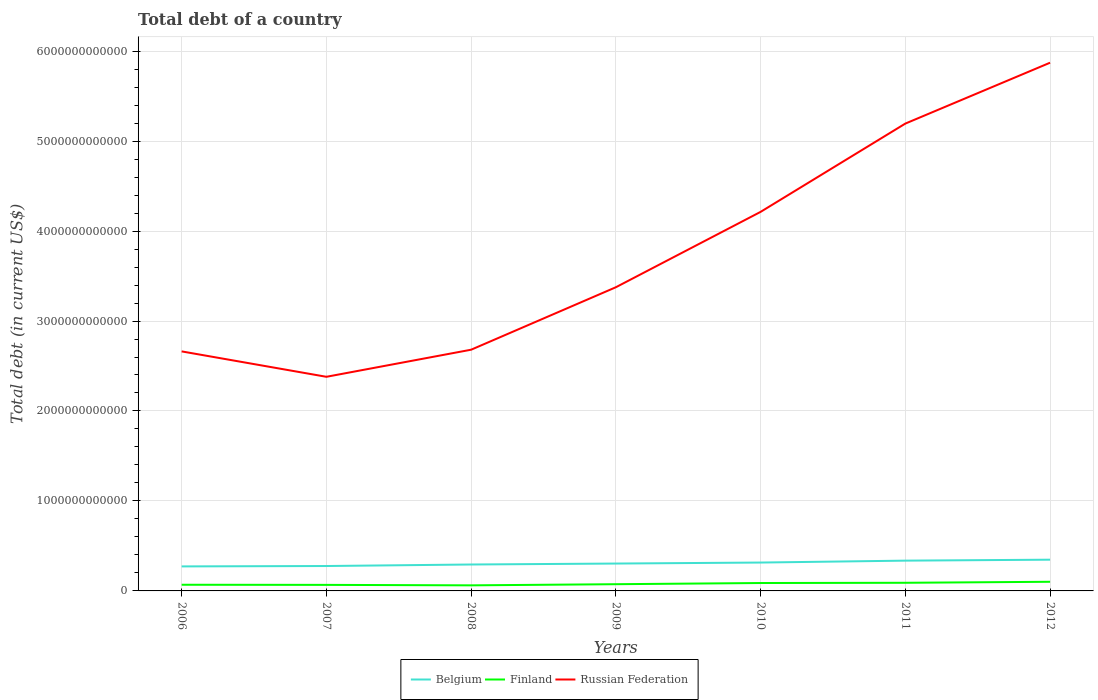Does the line corresponding to Belgium intersect with the line corresponding to Russian Federation?
Your answer should be compact. No. Is the number of lines equal to the number of legend labels?
Give a very brief answer. Yes. Across all years, what is the maximum debt in Belgium?
Your answer should be compact. 2.72e+11. In which year was the debt in Russian Federation maximum?
Provide a short and direct response. 2007. What is the total debt in Finland in the graph?
Your answer should be very brief. -1.58e+1. What is the difference between the highest and the second highest debt in Finland?
Your answer should be compact. 3.96e+1. Is the debt in Belgium strictly greater than the debt in Finland over the years?
Your answer should be very brief. No. How many lines are there?
Offer a terse response. 3. How many years are there in the graph?
Ensure brevity in your answer.  7. What is the difference between two consecutive major ticks on the Y-axis?
Your answer should be very brief. 1.00e+12. Does the graph contain any zero values?
Provide a succinct answer. No. What is the title of the graph?
Offer a very short reply. Total debt of a country. What is the label or title of the Y-axis?
Provide a short and direct response. Total debt (in current US$). What is the Total debt (in current US$) in Belgium in 2006?
Your answer should be very brief. 2.72e+11. What is the Total debt (in current US$) of Finland in 2006?
Offer a very short reply. 6.85e+1. What is the Total debt (in current US$) in Russian Federation in 2006?
Provide a succinct answer. 2.66e+12. What is the Total debt (in current US$) of Belgium in 2007?
Your response must be concise. 2.77e+11. What is the Total debt (in current US$) of Finland in 2007?
Provide a succinct answer. 6.72e+1. What is the Total debt (in current US$) of Russian Federation in 2007?
Ensure brevity in your answer.  2.38e+12. What is the Total debt (in current US$) of Belgium in 2008?
Give a very brief answer. 2.94e+11. What is the Total debt (in current US$) in Finland in 2008?
Offer a very short reply. 6.19e+1. What is the Total debt (in current US$) in Russian Federation in 2008?
Keep it short and to the point. 2.68e+12. What is the Total debt (in current US$) of Belgium in 2009?
Your response must be concise. 3.04e+11. What is the Total debt (in current US$) of Finland in 2009?
Your answer should be very brief. 7.47e+1. What is the Total debt (in current US$) of Russian Federation in 2009?
Keep it short and to the point. 3.38e+12. What is the Total debt (in current US$) of Belgium in 2010?
Provide a succinct answer. 3.15e+11. What is the Total debt (in current US$) of Finland in 2010?
Your answer should be very brief. 8.79e+1. What is the Total debt (in current US$) in Russian Federation in 2010?
Ensure brevity in your answer.  4.21e+12. What is the Total debt (in current US$) of Belgium in 2011?
Offer a terse response. 3.37e+11. What is the Total debt (in current US$) in Finland in 2011?
Offer a terse response. 9.05e+1. What is the Total debt (in current US$) in Russian Federation in 2011?
Provide a short and direct response. 5.19e+12. What is the Total debt (in current US$) of Belgium in 2012?
Keep it short and to the point. 3.47e+11. What is the Total debt (in current US$) of Finland in 2012?
Your answer should be compact. 1.02e+11. What is the Total debt (in current US$) of Russian Federation in 2012?
Your answer should be very brief. 5.87e+12. Across all years, what is the maximum Total debt (in current US$) of Belgium?
Offer a terse response. 3.47e+11. Across all years, what is the maximum Total debt (in current US$) in Finland?
Your response must be concise. 1.02e+11. Across all years, what is the maximum Total debt (in current US$) of Russian Federation?
Make the answer very short. 5.87e+12. Across all years, what is the minimum Total debt (in current US$) in Belgium?
Your answer should be very brief. 2.72e+11. Across all years, what is the minimum Total debt (in current US$) in Finland?
Keep it short and to the point. 6.19e+1. Across all years, what is the minimum Total debt (in current US$) of Russian Federation?
Make the answer very short. 2.38e+12. What is the total Total debt (in current US$) in Belgium in the graph?
Provide a short and direct response. 2.15e+12. What is the total Total debt (in current US$) in Finland in the graph?
Provide a succinct answer. 5.52e+11. What is the total Total debt (in current US$) of Russian Federation in the graph?
Provide a succinct answer. 2.64e+13. What is the difference between the Total debt (in current US$) in Belgium in 2006 and that in 2007?
Give a very brief answer. -4.37e+09. What is the difference between the Total debt (in current US$) of Finland in 2006 and that in 2007?
Your answer should be very brief. 1.32e+09. What is the difference between the Total debt (in current US$) in Russian Federation in 2006 and that in 2007?
Provide a succinct answer. 2.82e+11. What is the difference between the Total debt (in current US$) in Belgium in 2006 and that in 2008?
Ensure brevity in your answer.  -2.12e+1. What is the difference between the Total debt (in current US$) in Finland in 2006 and that in 2008?
Offer a terse response. 6.59e+09. What is the difference between the Total debt (in current US$) in Russian Federation in 2006 and that in 2008?
Ensure brevity in your answer.  -1.87e+1. What is the difference between the Total debt (in current US$) in Belgium in 2006 and that in 2009?
Make the answer very short. -3.18e+1. What is the difference between the Total debt (in current US$) of Finland in 2006 and that in 2009?
Keep it short and to the point. -6.14e+09. What is the difference between the Total debt (in current US$) of Russian Federation in 2006 and that in 2009?
Your answer should be very brief. -7.13e+11. What is the difference between the Total debt (in current US$) in Belgium in 2006 and that in 2010?
Keep it short and to the point. -4.30e+1. What is the difference between the Total debt (in current US$) in Finland in 2006 and that in 2010?
Your answer should be very brief. -1.94e+1. What is the difference between the Total debt (in current US$) of Russian Federation in 2006 and that in 2010?
Ensure brevity in your answer.  -1.55e+12. What is the difference between the Total debt (in current US$) in Belgium in 2006 and that in 2011?
Ensure brevity in your answer.  -6.41e+1. What is the difference between the Total debt (in current US$) in Finland in 2006 and that in 2011?
Give a very brief answer. -2.20e+1. What is the difference between the Total debt (in current US$) of Russian Federation in 2006 and that in 2011?
Your answer should be very brief. -2.53e+12. What is the difference between the Total debt (in current US$) of Belgium in 2006 and that in 2012?
Your response must be concise. -7.48e+1. What is the difference between the Total debt (in current US$) of Finland in 2006 and that in 2012?
Keep it short and to the point. -3.30e+1. What is the difference between the Total debt (in current US$) in Russian Federation in 2006 and that in 2012?
Keep it short and to the point. -3.21e+12. What is the difference between the Total debt (in current US$) in Belgium in 2007 and that in 2008?
Your answer should be compact. -1.69e+1. What is the difference between the Total debt (in current US$) of Finland in 2007 and that in 2008?
Provide a short and direct response. 5.27e+09. What is the difference between the Total debt (in current US$) of Russian Federation in 2007 and that in 2008?
Offer a terse response. -3.01e+11. What is the difference between the Total debt (in current US$) of Belgium in 2007 and that in 2009?
Give a very brief answer. -2.75e+1. What is the difference between the Total debt (in current US$) in Finland in 2007 and that in 2009?
Your answer should be compact. -7.46e+09. What is the difference between the Total debt (in current US$) in Russian Federation in 2007 and that in 2009?
Provide a succinct answer. -9.95e+11. What is the difference between the Total debt (in current US$) in Belgium in 2007 and that in 2010?
Your answer should be compact. -3.86e+1. What is the difference between the Total debt (in current US$) of Finland in 2007 and that in 2010?
Provide a short and direct response. -2.07e+1. What is the difference between the Total debt (in current US$) in Russian Federation in 2007 and that in 2010?
Offer a terse response. -1.83e+12. What is the difference between the Total debt (in current US$) in Belgium in 2007 and that in 2011?
Your answer should be very brief. -5.98e+1. What is the difference between the Total debt (in current US$) of Finland in 2007 and that in 2011?
Your answer should be compact. -2.33e+1. What is the difference between the Total debt (in current US$) of Russian Federation in 2007 and that in 2011?
Give a very brief answer. -2.81e+12. What is the difference between the Total debt (in current US$) in Belgium in 2007 and that in 2012?
Provide a succinct answer. -7.05e+1. What is the difference between the Total debt (in current US$) in Finland in 2007 and that in 2012?
Give a very brief answer. -3.43e+1. What is the difference between the Total debt (in current US$) in Russian Federation in 2007 and that in 2012?
Ensure brevity in your answer.  -3.49e+12. What is the difference between the Total debt (in current US$) in Belgium in 2008 and that in 2009?
Ensure brevity in your answer.  -1.06e+1. What is the difference between the Total debt (in current US$) of Finland in 2008 and that in 2009?
Offer a terse response. -1.27e+1. What is the difference between the Total debt (in current US$) in Russian Federation in 2008 and that in 2009?
Offer a terse response. -6.94e+11. What is the difference between the Total debt (in current US$) of Belgium in 2008 and that in 2010?
Your answer should be compact. -2.18e+1. What is the difference between the Total debt (in current US$) of Finland in 2008 and that in 2010?
Your answer should be very brief. -2.60e+1. What is the difference between the Total debt (in current US$) in Russian Federation in 2008 and that in 2010?
Your answer should be compact. -1.53e+12. What is the difference between the Total debt (in current US$) of Belgium in 2008 and that in 2011?
Your answer should be compact. -4.29e+1. What is the difference between the Total debt (in current US$) in Finland in 2008 and that in 2011?
Provide a succinct answer. -2.86e+1. What is the difference between the Total debt (in current US$) of Russian Federation in 2008 and that in 2011?
Your answer should be very brief. -2.51e+12. What is the difference between the Total debt (in current US$) in Belgium in 2008 and that in 2012?
Ensure brevity in your answer.  -5.36e+1. What is the difference between the Total debt (in current US$) of Finland in 2008 and that in 2012?
Provide a short and direct response. -3.96e+1. What is the difference between the Total debt (in current US$) in Russian Federation in 2008 and that in 2012?
Provide a short and direct response. -3.19e+12. What is the difference between the Total debt (in current US$) in Belgium in 2009 and that in 2010?
Your answer should be compact. -1.12e+1. What is the difference between the Total debt (in current US$) of Finland in 2009 and that in 2010?
Provide a short and direct response. -1.33e+1. What is the difference between the Total debt (in current US$) of Russian Federation in 2009 and that in 2010?
Keep it short and to the point. -8.38e+11. What is the difference between the Total debt (in current US$) in Belgium in 2009 and that in 2011?
Offer a very short reply. -3.23e+1. What is the difference between the Total debt (in current US$) in Finland in 2009 and that in 2011?
Your answer should be very brief. -1.58e+1. What is the difference between the Total debt (in current US$) of Russian Federation in 2009 and that in 2011?
Your response must be concise. -1.82e+12. What is the difference between the Total debt (in current US$) of Belgium in 2009 and that in 2012?
Provide a short and direct response. -4.30e+1. What is the difference between the Total debt (in current US$) of Finland in 2009 and that in 2012?
Give a very brief answer. -2.69e+1. What is the difference between the Total debt (in current US$) of Russian Federation in 2009 and that in 2012?
Offer a very short reply. -2.50e+12. What is the difference between the Total debt (in current US$) in Belgium in 2010 and that in 2011?
Offer a terse response. -2.11e+1. What is the difference between the Total debt (in current US$) of Finland in 2010 and that in 2011?
Offer a very short reply. -2.55e+09. What is the difference between the Total debt (in current US$) of Russian Federation in 2010 and that in 2011?
Offer a very short reply. -9.81e+11. What is the difference between the Total debt (in current US$) of Belgium in 2010 and that in 2012?
Provide a short and direct response. -3.18e+1. What is the difference between the Total debt (in current US$) in Finland in 2010 and that in 2012?
Provide a short and direct response. -1.36e+1. What is the difference between the Total debt (in current US$) in Russian Federation in 2010 and that in 2012?
Provide a short and direct response. -1.66e+12. What is the difference between the Total debt (in current US$) in Belgium in 2011 and that in 2012?
Ensure brevity in your answer.  -1.07e+1. What is the difference between the Total debt (in current US$) of Finland in 2011 and that in 2012?
Offer a terse response. -1.11e+1. What is the difference between the Total debt (in current US$) of Russian Federation in 2011 and that in 2012?
Keep it short and to the point. -6.77e+11. What is the difference between the Total debt (in current US$) of Belgium in 2006 and the Total debt (in current US$) of Finland in 2007?
Make the answer very short. 2.05e+11. What is the difference between the Total debt (in current US$) of Belgium in 2006 and the Total debt (in current US$) of Russian Federation in 2007?
Your answer should be very brief. -2.11e+12. What is the difference between the Total debt (in current US$) in Finland in 2006 and the Total debt (in current US$) in Russian Federation in 2007?
Your response must be concise. -2.31e+12. What is the difference between the Total debt (in current US$) in Belgium in 2006 and the Total debt (in current US$) in Finland in 2008?
Offer a terse response. 2.10e+11. What is the difference between the Total debt (in current US$) in Belgium in 2006 and the Total debt (in current US$) in Russian Federation in 2008?
Make the answer very short. -2.41e+12. What is the difference between the Total debt (in current US$) of Finland in 2006 and the Total debt (in current US$) of Russian Federation in 2008?
Offer a terse response. -2.61e+12. What is the difference between the Total debt (in current US$) of Belgium in 2006 and the Total debt (in current US$) of Finland in 2009?
Offer a very short reply. 1.98e+11. What is the difference between the Total debt (in current US$) of Belgium in 2006 and the Total debt (in current US$) of Russian Federation in 2009?
Keep it short and to the point. -3.10e+12. What is the difference between the Total debt (in current US$) of Finland in 2006 and the Total debt (in current US$) of Russian Federation in 2009?
Make the answer very short. -3.31e+12. What is the difference between the Total debt (in current US$) of Belgium in 2006 and the Total debt (in current US$) of Finland in 2010?
Provide a succinct answer. 1.84e+11. What is the difference between the Total debt (in current US$) of Belgium in 2006 and the Total debt (in current US$) of Russian Federation in 2010?
Your answer should be compact. -3.94e+12. What is the difference between the Total debt (in current US$) of Finland in 2006 and the Total debt (in current US$) of Russian Federation in 2010?
Offer a terse response. -4.14e+12. What is the difference between the Total debt (in current US$) of Belgium in 2006 and the Total debt (in current US$) of Finland in 2011?
Offer a very short reply. 1.82e+11. What is the difference between the Total debt (in current US$) in Belgium in 2006 and the Total debt (in current US$) in Russian Federation in 2011?
Offer a terse response. -4.92e+12. What is the difference between the Total debt (in current US$) in Finland in 2006 and the Total debt (in current US$) in Russian Federation in 2011?
Make the answer very short. -5.13e+12. What is the difference between the Total debt (in current US$) in Belgium in 2006 and the Total debt (in current US$) in Finland in 2012?
Give a very brief answer. 1.71e+11. What is the difference between the Total debt (in current US$) of Belgium in 2006 and the Total debt (in current US$) of Russian Federation in 2012?
Your answer should be very brief. -5.60e+12. What is the difference between the Total debt (in current US$) in Finland in 2006 and the Total debt (in current US$) in Russian Federation in 2012?
Your response must be concise. -5.80e+12. What is the difference between the Total debt (in current US$) of Belgium in 2007 and the Total debt (in current US$) of Finland in 2008?
Provide a succinct answer. 2.15e+11. What is the difference between the Total debt (in current US$) in Belgium in 2007 and the Total debt (in current US$) in Russian Federation in 2008?
Make the answer very short. -2.40e+12. What is the difference between the Total debt (in current US$) of Finland in 2007 and the Total debt (in current US$) of Russian Federation in 2008?
Your response must be concise. -2.61e+12. What is the difference between the Total debt (in current US$) of Belgium in 2007 and the Total debt (in current US$) of Finland in 2009?
Your answer should be very brief. 2.02e+11. What is the difference between the Total debt (in current US$) in Belgium in 2007 and the Total debt (in current US$) in Russian Federation in 2009?
Provide a succinct answer. -3.10e+12. What is the difference between the Total debt (in current US$) in Finland in 2007 and the Total debt (in current US$) in Russian Federation in 2009?
Offer a terse response. -3.31e+12. What is the difference between the Total debt (in current US$) in Belgium in 2007 and the Total debt (in current US$) in Finland in 2010?
Keep it short and to the point. 1.89e+11. What is the difference between the Total debt (in current US$) of Belgium in 2007 and the Total debt (in current US$) of Russian Federation in 2010?
Your answer should be very brief. -3.94e+12. What is the difference between the Total debt (in current US$) of Finland in 2007 and the Total debt (in current US$) of Russian Federation in 2010?
Provide a succinct answer. -4.15e+12. What is the difference between the Total debt (in current US$) in Belgium in 2007 and the Total debt (in current US$) in Finland in 2011?
Give a very brief answer. 1.86e+11. What is the difference between the Total debt (in current US$) in Belgium in 2007 and the Total debt (in current US$) in Russian Federation in 2011?
Provide a short and direct response. -4.92e+12. What is the difference between the Total debt (in current US$) of Finland in 2007 and the Total debt (in current US$) of Russian Federation in 2011?
Keep it short and to the point. -5.13e+12. What is the difference between the Total debt (in current US$) in Belgium in 2007 and the Total debt (in current US$) in Finland in 2012?
Make the answer very short. 1.75e+11. What is the difference between the Total debt (in current US$) in Belgium in 2007 and the Total debt (in current US$) in Russian Federation in 2012?
Keep it short and to the point. -5.59e+12. What is the difference between the Total debt (in current US$) in Finland in 2007 and the Total debt (in current US$) in Russian Federation in 2012?
Provide a succinct answer. -5.80e+12. What is the difference between the Total debt (in current US$) of Belgium in 2008 and the Total debt (in current US$) of Finland in 2009?
Provide a short and direct response. 2.19e+11. What is the difference between the Total debt (in current US$) of Belgium in 2008 and the Total debt (in current US$) of Russian Federation in 2009?
Give a very brief answer. -3.08e+12. What is the difference between the Total debt (in current US$) of Finland in 2008 and the Total debt (in current US$) of Russian Federation in 2009?
Provide a succinct answer. -3.31e+12. What is the difference between the Total debt (in current US$) of Belgium in 2008 and the Total debt (in current US$) of Finland in 2010?
Give a very brief answer. 2.06e+11. What is the difference between the Total debt (in current US$) in Belgium in 2008 and the Total debt (in current US$) in Russian Federation in 2010?
Offer a terse response. -3.92e+12. What is the difference between the Total debt (in current US$) in Finland in 2008 and the Total debt (in current US$) in Russian Federation in 2010?
Your response must be concise. -4.15e+12. What is the difference between the Total debt (in current US$) in Belgium in 2008 and the Total debt (in current US$) in Finland in 2011?
Your answer should be very brief. 2.03e+11. What is the difference between the Total debt (in current US$) in Belgium in 2008 and the Total debt (in current US$) in Russian Federation in 2011?
Make the answer very short. -4.90e+12. What is the difference between the Total debt (in current US$) in Finland in 2008 and the Total debt (in current US$) in Russian Federation in 2011?
Offer a terse response. -5.13e+12. What is the difference between the Total debt (in current US$) in Belgium in 2008 and the Total debt (in current US$) in Finland in 2012?
Provide a succinct answer. 1.92e+11. What is the difference between the Total debt (in current US$) in Belgium in 2008 and the Total debt (in current US$) in Russian Federation in 2012?
Your answer should be very brief. -5.58e+12. What is the difference between the Total debt (in current US$) of Finland in 2008 and the Total debt (in current US$) of Russian Federation in 2012?
Ensure brevity in your answer.  -5.81e+12. What is the difference between the Total debt (in current US$) of Belgium in 2009 and the Total debt (in current US$) of Finland in 2010?
Keep it short and to the point. 2.16e+11. What is the difference between the Total debt (in current US$) of Belgium in 2009 and the Total debt (in current US$) of Russian Federation in 2010?
Make the answer very short. -3.91e+12. What is the difference between the Total debt (in current US$) of Finland in 2009 and the Total debt (in current US$) of Russian Federation in 2010?
Give a very brief answer. -4.14e+12. What is the difference between the Total debt (in current US$) in Belgium in 2009 and the Total debt (in current US$) in Finland in 2011?
Make the answer very short. 2.14e+11. What is the difference between the Total debt (in current US$) in Belgium in 2009 and the Total debt (in current US$) in Russian Federation in 2011?
Provide a short and direct response. -4.89e+12. What is the difference between the Total debt (in current US$) of Finland in 2009 and the Total debt (in current US$) of Russian Federation in 2011?
Your answer should be compact. -5.12e+12. What is the difference between the Total debt (in current US$) in Belgium in 2009 and the Total debt (in current US$) in Finland in 2012?
Give a very brief answer. 2.03e+11. What is the difference between the Total debt (in current US$) in Belgium in 2009 and the Total debt (in current US$) in Russian Federation in 2012?
Offer a very short reply. -5.57e+12. What is the difference between the Total debt (in current US$) of Finland in 2009 and the Total debt (in current US$) of Russian Federation in 2012?
Offer a very short reply. -5.80e+12. What is the difference between the Total debt (in current US$) in Belgium in 2010 and the Total debt (in current US$) in Finland in 2011?
Your response must be concise. 2.25e+11. What is the difference between the Total debt (in current US$) of Belgium in 2010 and the Total debt (in current US$) of Russian Federation in 2011?
Your answer should be compact. -4.88e+12. What is the difference between the Total debt (in current US$) of Finland in 2010 and the Total debt (in current US$) of Russian Federation in 2011?
Offer a very short reply. -5.11e+12. What is the difference between the Total debt (in current US$) of Belgium in 2010 and the Total debt (in current US$) of Finland in 2012?
Provide a succinct answer. 2.14e+11. What is the difference between the Total debt (in current US$) of Belgium in 2010 and the Total debt (in current US$) of Russian Federation in 2012?
Ensure brevity in your answer.  -5.56e+12. What is the difference between the Total debt (in current US$) in Finland in 2010 and the Total debt (in current US$) in Russian Federation in 2012?
Your answer should be compact. -5.78e+12. What is the difference between the Total debt (in current US$) of Belgium in 2011 and the Total debt (in current US$) of Finland in 2012?
Make the answer very short. 2.35e+11. What is the difference between the Total debt (in current US$) of Belgium in 2011 and the Total debt (in current US$) of Russian Federation in 2012?
Give a very brief answer. -5.53e+12. What is the difference between the Total debt (in current US$) of Finland in 2011 and the Total debt (in current US$) of Russian Federation in 2012?
Your answer should be very brief. -5.78e+12. What is the average Total debt (in current US$) of Belgium per year?
Provide a short and direct response. 3.07e+11. What is the average Total debt (in current US$) in Finland per year?
Ensure brevity in your answer.  7.89e+1. What is the average Total debt (in current US$) in Russian Federation per year?
Keep it short and to the point. 3.77e+12. In the year 2006, what is the difference between the Total debt (in current US$) in Belgium and Total debt (in current US$) in Finland?
Your response must be concise. 2.04e+11. In the year 2006, what is the difference between the Total debt (in current US$) in Belgium and Total debt (in current US$) in Russian Federation?
Offer a terse response. -2.39e+12. In the year 2006, what is the difference between the Total debt (in current US$) in Finland and Total debt (in current US$) in Russian Federation?
Offer a very short reply. -2.59e+12. In the year 2007, what is the difference between the Total debt (in current US$) in Belgium and Total debt (in current US$) in Finland?
Ensure brevity in your answer.  2.10e+11. In the year 2007, what is the difference between the Total debt (in current US$) of Belgium and Total debt (in current US$) of Russian Federation?
Provide a succinct answer. -2.10e+12. In the year 2007, what is the difference between the Total debt (in current US$) of Finland and Total debt (in current US$) of Russian Federation?
Your answer should be compact. -2.31e+12. In the year 2008, what is the difference between the Total debt (in current US$) of Belgium and Total debt (in current US$) of Finland?
Offer a terse response. 2.32e+11. In the year 2008, what is the difference between the Total debt (in current US$) of Belgium and Total debt (in current US$) of Russian Federation?
Give a very brief answer. -2.39e+12. In the year 2008, what is the difference between the Total debt (in current US$) in Finland and Total debt (in current US$) in Russian Federation?
Make the answer very short. -2.62e+12. In the year 2009, what is the difference between the Total debt (in current US$) in Belgium and Total debt (in current US$) in Finland?
Give a very brief answer. 2.30e+11. In the year 2009, what is the difference between the Total debt (in current US$) in Belgium and Total debt (in current US$) in Russian Federation?
Provide a short and direct response. -3.07e+12. In the year 2009, what is the difference between the Total debt (in current US$) of Finland and Total debt (in current US$) of Russian Federation?
Provide a short and direct response. -3.30e+12. In the year 2010, what is the difference between the Total debt (in current US$) of Belgium and Total debt (in current US$) of Finland?
Your answer should be compact. 2.27e+11. In the year 2010, what is the difference between the Total debt (in current US$) of Belgium and Total debt (in current US$) of Russian Federation?
Provide a short and direct response. -3.90e+12. In the year 2010, what is the difference between the Total debt (in current US$) in Finland and Total debt (in current US$) in Russian Federation?
Keep it short and to the point. -4.13e+12. In the year 2011, what is the difference between the Total debt (in current US$) in Belgium and Total debt (in current US$) in Finland?
Provide a short and direct response. 2.46e+11. In the year 2011, what is the difference between the Total debt (in current US$) of Belgium and Total debt (in current US$) of Russian Federation?
Offer a terse response. -4.86e+12. In the year 2011, what is the difference between the Total debt (in current US$) of Finland and Total debt (in current US$) of Russian Federation?
Provide a succinct answer. -5.10e+12. In the year 2012, what is the difference between the Total debt (in current US$) of Belgium and Total debt (in current US$) of Finland?
Give a very brief answer. 2.46e+11. In the year 2012, what is the difference between the Total debt (in current US$) in Belgium and Total debt (in current US$) in Russian Federation?
Make the answer very short. -5.52e+12. In the year 2012, what is the difference between the Total debt (in current US$) of Finland and Total debt (in current US$) of Russian Federation?
Keep it short and to the point. -5.77e+12. What is the ratio of the Total debt (in current US$) in Belgium in 2006 to that in 2007?
Keep it short and to the point. 0.98. What is the ratio of the Total debt (in current US$) in Finland in 2006 to that in 2007?
Offer a very short reply. 1.02. What is the ratio of the Total debt (in current US$) of Russian Federation in 2006 to that in 2007?
Offer a very short reply. 1.12. What is the ratio of the Total debt (in current US$) in Belgium in 2006 to that in 2008?
Provide a short and direct response. 0.93. What is the ratio of the Total debt (in current US$) of Finland in 2006 to that in 2008?
Your response must be concise. 1.11. What is the ratio of the Total debt (in current US$) in Belgium in 2006 to that in 2009?
Keep it short and to the point. 0.9. What is the ratio of the Total debt (in current US$) of Finland in 2006 to that in 2009?
Ensure brevity in your answer.  0.92. What is the ratio of the Total debt (in current US$) of Russian Federation in 2006 to that in 2009?
Ensure brevity in your answer.  0.79. What is the ratio of the Total debt (in current US$) of Belgium in 2006 to that in 2010?
Offer a very short reply. 0.86. What is the ratio of the Total debt (in current US$) of Finland in 2006 to that in 2010?
Your response must be concise. 0.78. What is the ratio of the Total debt (in current US$) of Russian Federation in 2006 to that in 2010?
Make the answer very short. 0.63. What is the ratio of the Total debt (in current US$) in Belgium in 2006 to that in 2011?
Your answer should be compact. 0.81. What is the ratio of the Total debt (in current US$) in Finland in 2006 to that in 2011?
Provide a succinct answer. 0.76. What is the ratio of the Total debt (in current US$) of Russian Federation in 2006 to that in 2011?
Provide a short and direct response. 0.51. What is the ratio of the Total debt (in current US$) of Belgium in 2006 to that in 2012?
Offer a very short reply. 0.78. What is the ratio of the Total debt (in current US$) of Finland in 2006 to that in 2012?
Ensure brevity in your answer.  0.67. What is the ratio of the Total debt (in current US$) of Russian Federation in 2006 to that in 2012?
Offer a terse response. 0.45. What is the ratio of the Total debt (in current US$) in Belgium in 2007 to that in 2008?
Keep it short and to the point. 0.94. What is the ratio of the Total debt (in current US$) of Finland in 2007 to that in 2008?
Keep it short and to the point. 1.09. What is the ratio of the Total debt (in current US$) in Russian Federation in 2007 to that in 2008?
Offer a terse response. 0.89. What is the ratio of the Total debt (in current US$) in Belgium in 2007 to that in 2009?
Make the answer very short. 0.91. What is the ratio of the Total debt (in current US$) in Finland in 2007 to that in 2009?
Provide a short and direct response. 0.9. What is the ratio of the Total debt (in current US$) in Russian Federation in 2007 to that in 2009?
Keep it short and to the point. 0.71. What is the ratio of the Total debt (in current US$) of Belgium in 2007 to that in 2010?
Your answer should be compact. 0.88. What is the ratio of the Total debt (in current US$) of Finland in 2007 to that in 2010?
Ensure brevity in your answer.  0.76. What is the ratio of the Total debt (in current US$) in Russian Federation in 2007 to that in 2010?
Ensure brevity in your answer.  0.56. What is the ratio of the Total debt (in current US$) in Belgium in 2007 to that in 2011?
Keep it short and to the point. 0.82. What is the ratio of the Total debt (in current US$) in Finland in 2007 to that in 2011?
Your answer should be compact. 0.74. What is the ratio of the Total debt (in current US$) of Russian Federation in 2007 to that in 2011?
Ensure brevity in your answer.  0.46. What is the ratio of the Total debt (in current US$) in Belgium in 2007 to that in 2012?
Your answer should be compact. 0.8. What is the ratio of the Total debt (in current US$) of Finland in 2007 to that in 2012?
Provide a short and direct response. 0.66. What is the ratio of the Total debt (in current US$) of Russian Federation in 2007 to that in 2012?
Make the answer very short. 0.41. What is the ratio of the Total debt (in current US$) in Belgium in 2008 to that in 2009?
Your response must be concise. 0.97. What is the ratio of the Total debt (in current US$) of Finland in 2008 to that in 2009?
Give a very brief answer. 0.83. What is the ratio of the Total debt (in current US$) of Russian Federation in 2008 to that in 2009?
Provide a succinct answer. 0.79. What is the ratio of the Total debt (in current US$) in Belgium in 2008 to that in 2010?
Offer a terse response. 0.93. What is the ratio of the Total debt (in current US$) in Finland in 2008 to that in 2010?
Make the answer very short. 0.7. What is the ratio of the Total debt (in current US$) of Russian Federation in 2008 to that in 2010?
Offer a very short reply. 0.64. What is the ratio of the Total debt (in current US$) of Belgium in 2008 to that in 2011?
Your response must be concise. 0.87. What is the ratio of the Total debt (in current US$) of Finland in 2008 to that in 2011?
Your answer should be compact. 0.68. What is the ratio of the Total debt (in current US$) in Russian Federation in 2008 to that in 2011?
Provide a short and direct response. 0.52. What is the ratio of the Total debt (in current US$) in Belgium in 2008 to that in 2012?
Your answer should be very brief. 0.85. What is the ratio of the Total debt (in current US$) of Finland in 2008 to that in 2012?
Make the answer very short. 0.61. What is the ratio of the Total debt (in current US$) in Russian Federation in 2008 to that in 2012?
Make the answer very short. 0.46. What is the ratio of the Total debt (in current US$) in Belgium in 2009 to that in 2010?
Offer a terse response. 0.96. What is the ratio of the Total debt (in current US$) of Finland in 2009 to that in 2010?
Your answer should be very brief. 0.85. What is the ratio of the Total debt (in current US$) of Russian Federation in 2009 to that in 2010?
Your answer should be very brief. 0.8. What is the ratio of the Total debt (in current US$) in Belgium in 2009 to that in 2011?
Your response must be concise. 0.9. What is the ratio of the Total debt (in current US$) of Finland in 2009 to that in 2011?
Your answer should be very brief. 0.83. What is the ratio of the Total debt (in current US$) of Russian Federation in 2009 to that in 2011?
Offer a very short reply. 0.65. What is the ratio of the Total debt (in current US$) in Belgium in 2009 to that in 2012?
Keep it short and to the point. 0.88. What is the ratio of the Total debt (in current US$) in Finland in 2009 to that in 2012?
Your answer should be compact. 0.74. What is the ratio of the Total debt (in current US$) of Russian Federation in 2009 to that in 2012?
Your response must be concise. 0.57. What is the ratio of the Total debt (in current US$) of Belgium in 2010 to that in 2011?
Make the answer very short. 0.94. What is the ratio of the Total debt (in current US$) in Finland in 2010 to that in 2011?
Your answer should be very brief. 0.97. What is the ratio of the Total debt (in current US$) in Russian Federation in 2010 to that in 2011?
Keep it short and to the point. 0.81. What is the ratio of the Total debt (in current US$) in Belgium in 2010 to that in 2012?
Your answer should be compact. 0.91. What is the ratio of the Total debt (in current US$) of Finland in 2010 to that in 2012?
Provide a short and direct response. 0.87. What is the ratio of the Total debt (in current US$) of Russian Federation in 2010 to that in 2012?
Provide a succinct answer. 0.72. What is the ratio of the Total debt (in current US$) of Belgium in 2011 to that in 2012?
Give a very brief answer. 0.97. What is the ratio of the Total debt (in current US$) in Finland in 2011 to that in 2012?
Your response must be concise. 0.89. What is the ratio of the Total debt (in current US$) of Russian Federation in 2011 to that in 2012?
Ensure brevity in your answer.  0.88. What is the difference between the highest and the second highest Total debt (in current US$) of Belgium?
Provide a succinct answer. 1.07e+1. What is the difference between the highest and the second highest Total debt (in current US$) in Finland?
Your answer should be compact. 1.11e+1. What is the difference between the highest and the second highest Total debt (in current US$) in Russian Federation?
Your answer should be compact. 6.77e+11. What is the difference between the highest and the lowest Total debt (in current US$) in Belgium?
Offer a very short reply. 7.48e+1. What is the difference between the highest and the lowest Total debt (in current US$) in Finland?
Keep it short and to the point. 3.96e+1. What is the difference between the highest and the lowest Total debt (in current US$) in Russian Federation?
Your response must be concise. 3.49e+12. 